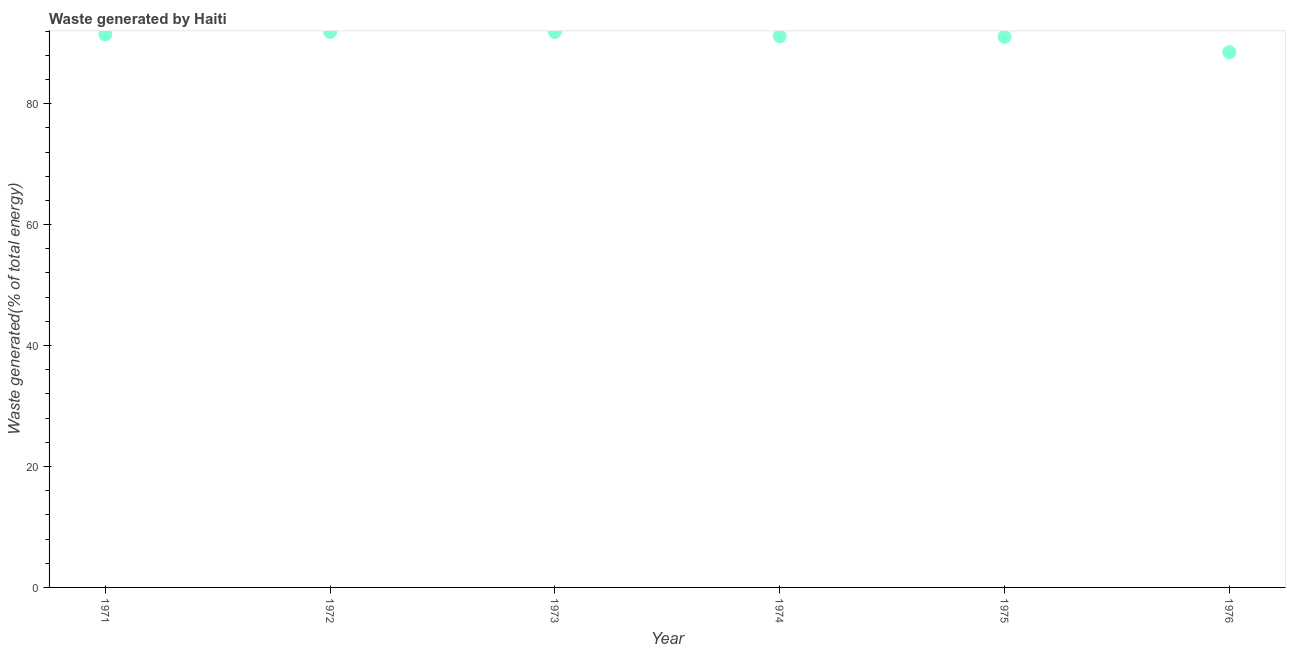What is the amount of waste generated in 1971?
Make the answer very short. 91.45. Across all years, what is the maximum amount of waste generated?
Your answer should be very brief. 91.88. Across all years, what is the minimum amount of waste generated?
Offer a very short reply. 88.51. In which year was the amount of waste generated minimum?
Make the answer very short. 1976. What is the sum of the amount of waste generated?
Your answer should be compact. 545.88. What is the difference between the amount of waste generated in 1972 and 1974?
Provide a short and direct response. 0.73. What is the average amount of waste generated per year?
Ensure brevity in your answer.  90.98. What is the median amount of waste generated?
Your answer should be very brief. 91.29. What is the ratio of the amount of waste generated in 1972 to that in 1975?
Provide a short and direct response. 1.01. Is the difference between the amount of waste generated in 1974 and 1975 greater than the difference between any two years?
Offer a terse response. No. What is the difference between the highest and the second highest amount of waste generated?
Ensure brevity in your answer.  0.02. What is the difference between the highest and the lowest amount of waste generated?
Your response must be concise. 3.37. In how many years, is the amount of waste generated greater than the average amount of waste generated taken over all years?
Provide a succinct answer. 5. Does the amount of waste generated monotonically increase over the years?
Make the answer very short. No. How many years are there in the graph?
Provide a short and direct response. 6. Are the values on the major ticks of Y-axis written in scientific E-notation?
Provide a succinct answer. No. Does the graph contain any zero values?
Provide a short and direct response. No. Does the graph contain grids?
Your answer should be very brief. No. What is the title of the graph?
Ensure brevity in your answer.  Waste generated by Haiti. What is the label or title of the X-axis?
Your response must be concise. Year. What is the label or title of the Y-axis?
Provide a succinct answer. Waste generated(% of total energy). What is the Waste generated(% of total energy) in 1971?
Keep it short and to the point. 91.45. What is the Waste generated(% of total energy) in 1972?
Provide a short and direct response. 91.88. What is the Waste generated(% of total energy) in 1973?
Ensure brevity in your answer.  91.85. What is the Waste generated(% of total energy) in 1974?
Your answer should be very brief. 91.14. What is the Waste generated(% of total energy) in 1975?
Offer a very short reply. 91.04. What is the Waste generated(% of total energy) in 1976?
Keep it short and to the point. 88.51. What is the difference between the Waste generated(% of total energy) in 1971 and 1972?
Your answer should be compact. -0.43. What is the difference between the Waste generated(% of total energy) in 1971 and 1973?
Offer a very short reply. -0.41. What is the difference between the Waste generated(% of total energy) in 1971 and 1974?
Offer a very short reply. 0.3. What is the difference between the Waste generated(% of total energy) in 1971 and 1975?
Make the answer very short. 0.4. What is the difference between the Waste generated(% of total energy) in 1971 and 1976?
Offer a terse response. 2.94. What is the difference between the Waste generated(% of total energy) in 1972 and 1973?
Keep it short and to the point. 0.02. What is the difference between the Waste generated(% of total energy) in 1972 and 1974?
Provide a succinct answer. 0.73. What is the difference between the Waste generated(% of total energy) in 1972 and 1975?
Offer a terse response. 0.83. What is the difference between the Waste generated(% of total energy) in 1972 and 1976?
Ensure brevity in your answer.  3.37. What is the difference between the Waste generated(% of total energy) in 1973 and 1974?
Provide a short and direct response. 0.71. What is the difference between the Waste generated(% of total energy) in 1973 and 1975?
Offer a very short reply. 0.81. What is the difference between the Waste generated(% of total energy) in 1973 and 1976?
Offer a terse response. 3.34. What is the difference between the Waste generated(% of total energy) in 1974 and 1975?
Ensure brevity in your answer.  0.1. What is the difference between the Waste generated(% of total energy) in 1974 and 1976?
Give a very brief answer. 2.63. What is the difference between the Waste generated(% of total energy) in 1975 and 1976?
Give a very brief answer. 2.54. What is the ratio of the Waste generated(% of total energy) in 1971 to that in 1973?
Your answer should be very brief. 1. What is the ratio of the Waste generated(% of total energy) in 1971 to that in 1974?
Provide a succinct answer. 1. What is the ratio of the Waste generated(% of total energy) in 1971 to that in 1976?
Your answer should be very brief. 1.03. What is the ratio of the Waste generated(% of total energy) in 1972 to that in 1973?
Your response must be concise. 1. What is the ratio of the Waste generated(% of total energy) in 1972 to that in 1976?
Your response must be concise. 1.04. What is the ratio of the Waste generated(% of total energy) in 1973 to that in 1974?
Offer a very short reply. 1.01. What is the ratio of the Waste generated(% of total energy) in 1973 to that in 1976?
Your answer should be compact. 1.04. What is the ratio of the Waste generated(% of total energy) in 1974 to that in 1975?
Give a very brief answer. 1. What is the ratio of the Waste generated(% of total energy) in 1975 to that in 1976?
Ensure brevity in your answer.  1.03. 